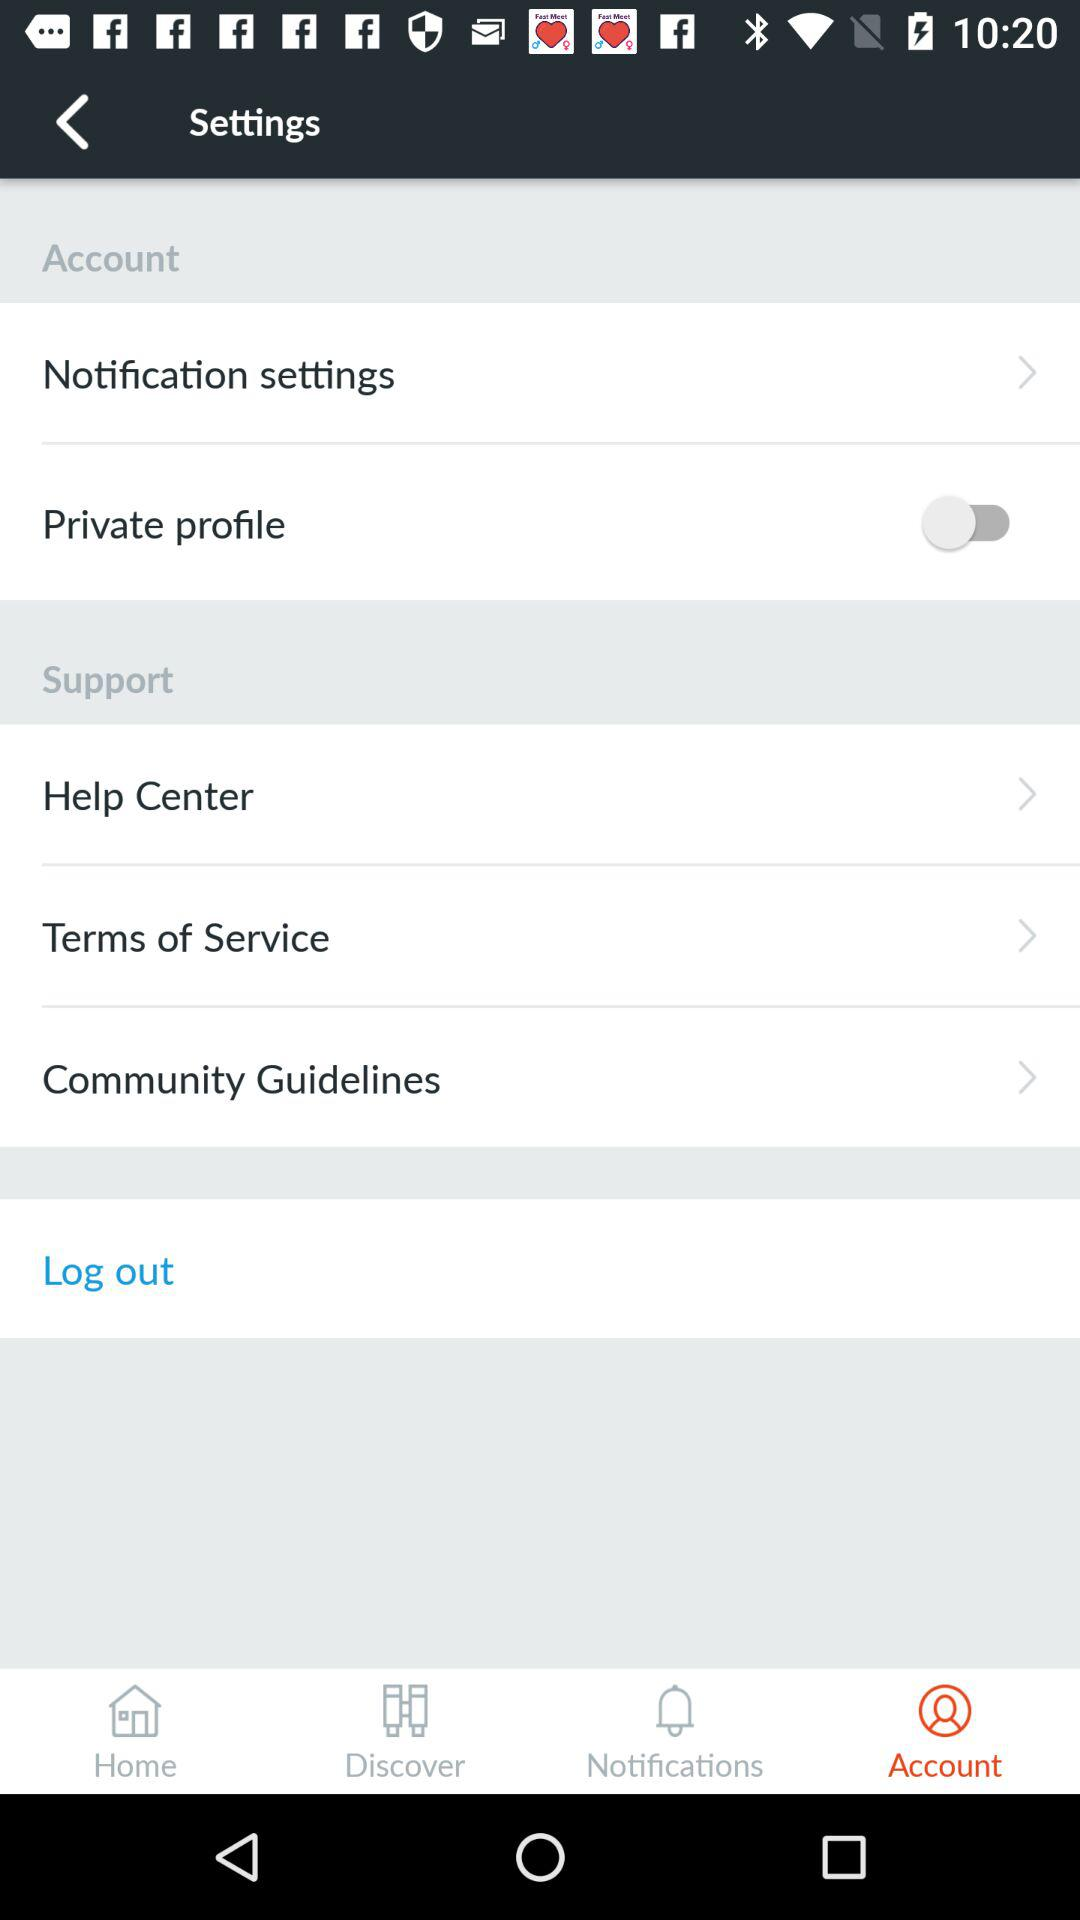What is the status of "Private profile"? The status of "Private profile" is "off". 